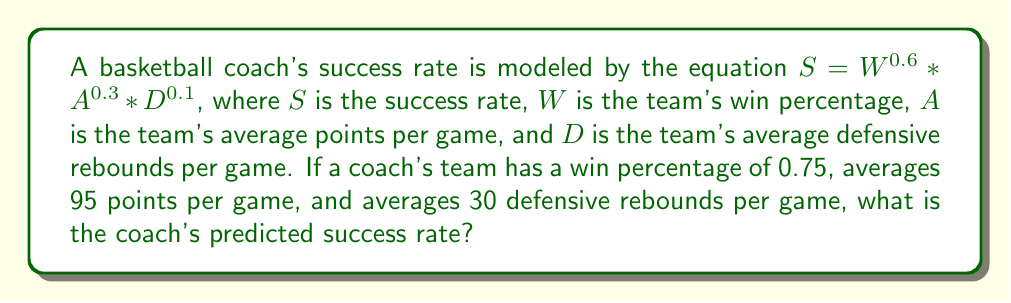Teach me how to tackle this problem. Let's solve this step-by-step:

1. We are given the equation: $S = W^{0.6} * A^{0.3} * D^{0.1}$

2. We know the following values:
   $W = 0.75$
   $A = 95$
   $D = 30$

3. Let's substitute these values into the equation:
   $S = (0.75)^{0.6} * (95)^{0.3} * (30)^{0.1}$

4. Now, let's calculate each term:
   $(0.75)^{0.6} = 0.8306$ (rounded to 4 decimal places)
   $(95)^{0.3} = 3.8833$ (rounded to 4 decimal places)
   $(30)^{0.1} = 1.3605$ (rounded to 4 decimal places)

5. Multiply these results:
   $S = 0.8306 * 3.8833 * 1.3605 = 4.3868$ (rounded to 4 decimal places)

Therefore, the coach's predicted success rate is approximately 4.3868.
Answer: 4.3868 